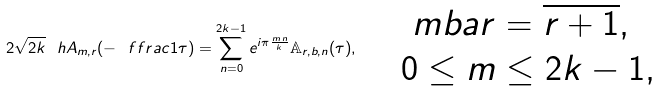Convert formula to latex. <formula><loc_0><loc_0><loc_500><loc_500>2 \sqrt { 2 k } \ h A _ { m , r } ( - \ f f r a c { 1 } { \tau } ) = \sum _ { n = 0 } ^ { 2 k - 1 } e ^ { i \pi \frac { m \, n } { k } } \mathbb { A } _ { r , b , n } ( \tau ) , \quad \begin{array} { l } \ m b a r = \overline { r + 1 } , \\ 0 \leq m \leq 2 k - 1 , \end{array}</formula> 